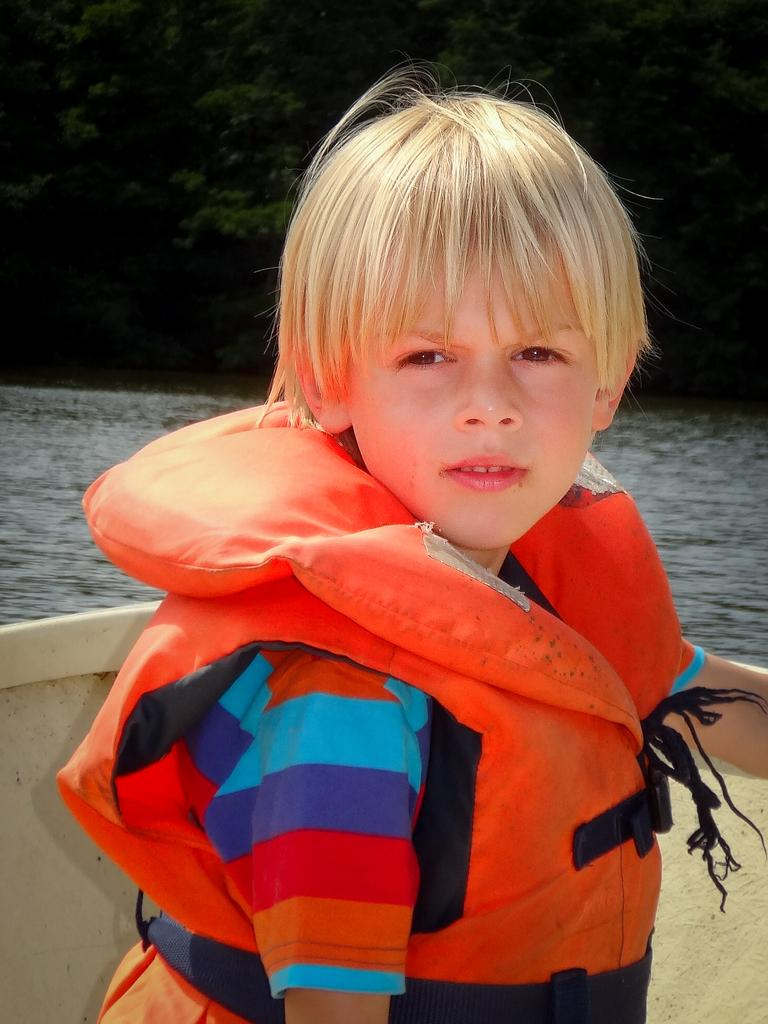Who is the main subject in the image? There is a boy in the image. What is the boy doing in the image? The boy is sitting on a boat. What is the boy wearing in the image? The boy is wearing an orange jacket. What can be seen in the background of the image? There is water and trees visible in the background of the image. What type of vase can be seen in the image? There is no vase present in the image. What game is the boy playing in the image? The image does not show the boy playing any game. 